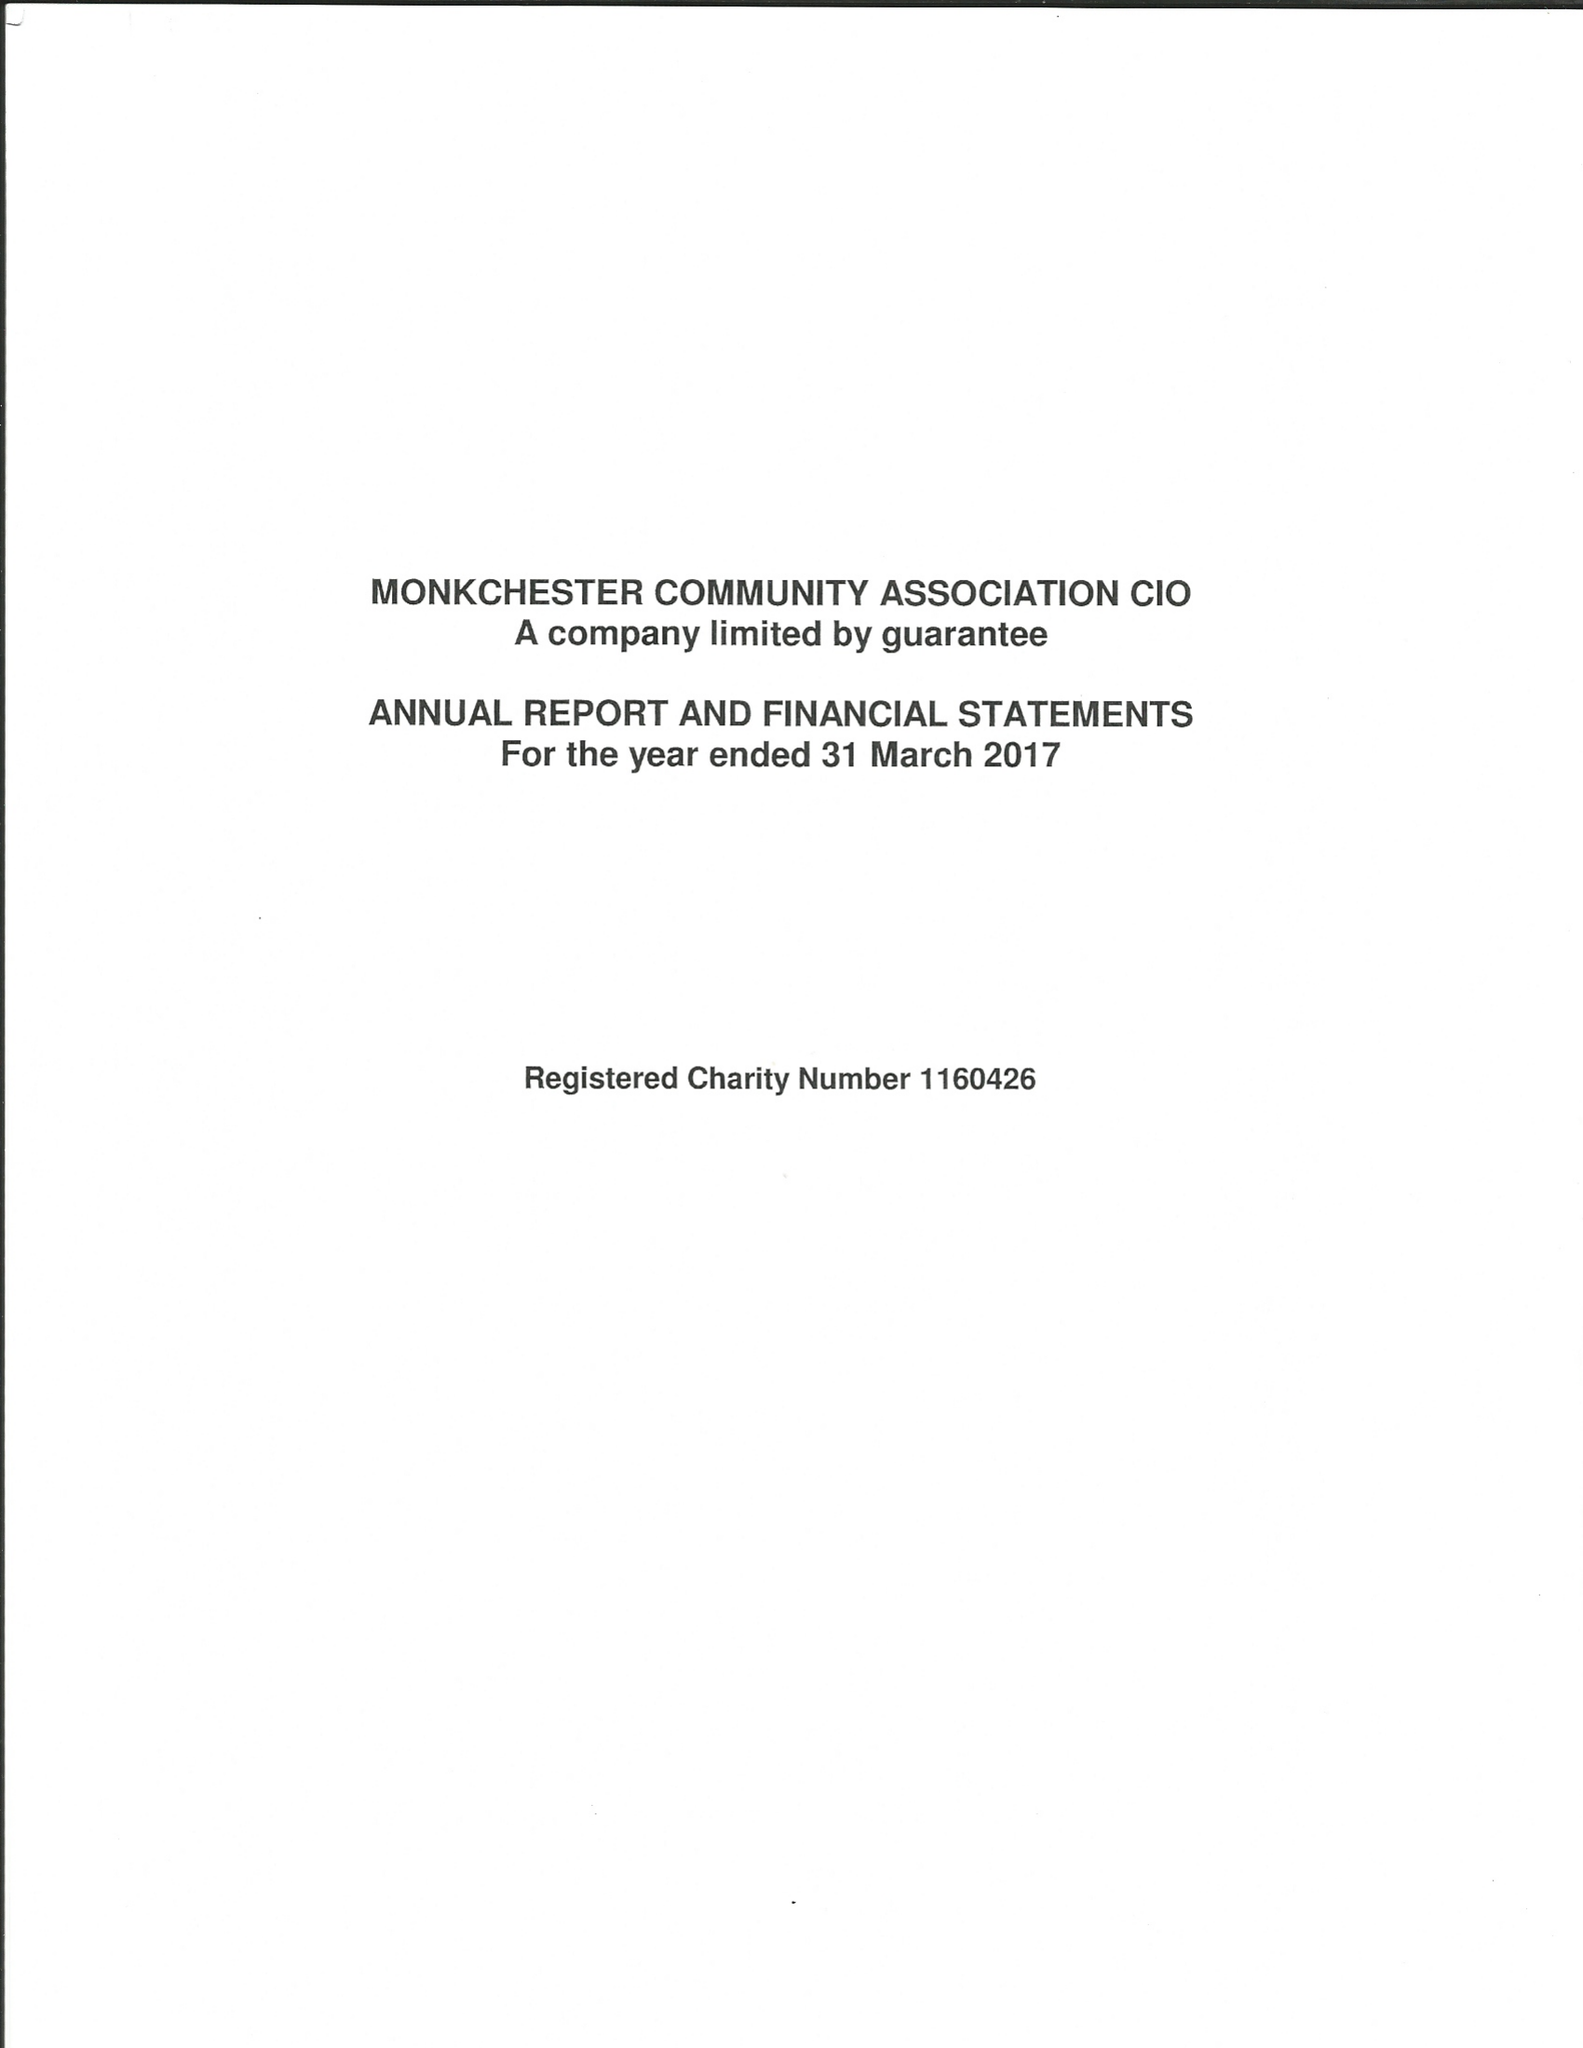What is the value for the income_annually_in_british_pounds?
Answer the question using a single word or phrase. 14131.00 